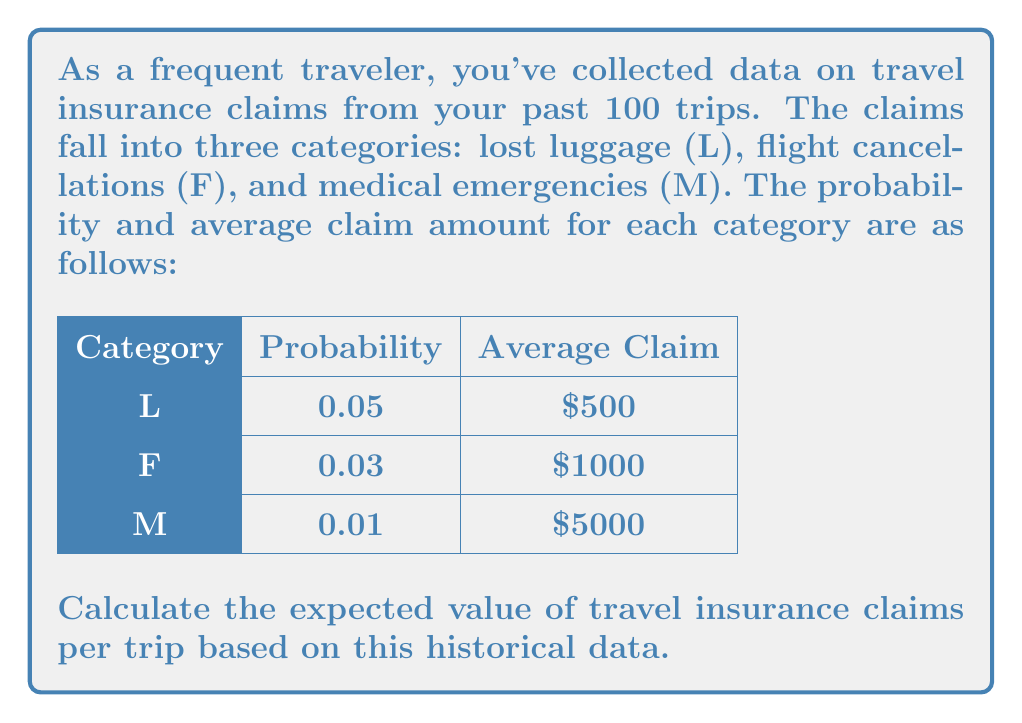Provide a solution to this math problem. To calculate the expected value of travel insurance claims, we need to follow these steps:

1) The expected value is the sum of each possible outcome multiplied by its probability.

2) For each category, we multiply the probability of occurrence by the average claim amount:

   Lost luggage (L): $E(L) = 0.05 \times \$500 = \$25$
   Flight cancellations (F): $E(F) = 0.03 \times \$1000 = \$30$
   Medical emergencies (M): $E(M) = 0.01 \times \$5000 = \$50$

3) The total expected value is the sum of these individual expected values:

   $E(\text{total}) = E(L) + E(F) + E(M)$
   $E(\text{total}) = \$25 + \$30 + \$50 = \$105$

Therefore, based on the historical data, the expected value of travel insurance claims per trip is $105.
Answer: $105 